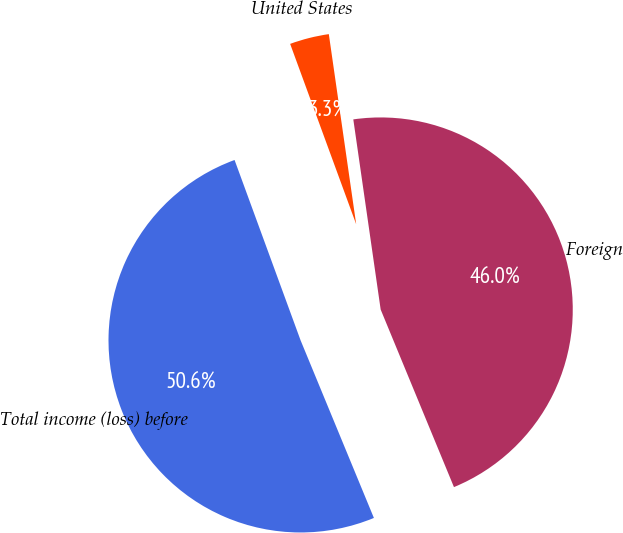Convert chart to OTSL. <chart><loc_0><loc_0><loc_500><loc_500><pie_chart><fcel>United States<fcel>Foreign<fcel>Total income (loss) before<nl><fcel>3.31%<fcel>46.04%<fcel>50.64%<nl></chart> 